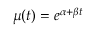Convert formula to latex. <formula><loc_0><loc_0><loc_500><loc_500>\mu ( t ) = e ^ { \alpha + \beta t }</formula> 